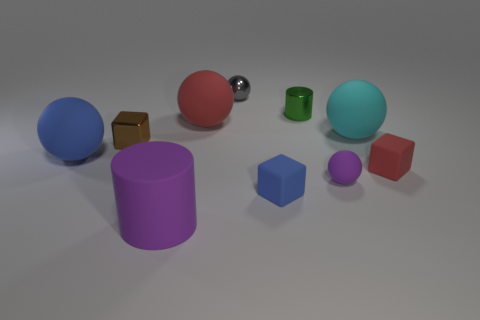Subtract all gray spheres. How many spheres are left? 4 Subtract 2 balls. How many balls are left? 3 Subtract all gray spheres. How many spheres are left? 4 Subtract all green balls. Subtract all gray cubes. How many balls are left? 5 Subtract all cubes. How many objects are left? 7 Add 5 small green metal objects. How many small green metal objects are left? 6 Add 4 cylinders. How many cylinders exist? 6 Subtract 0 green balls. How many objects are left? 10 Subtract all red spheres. Subtract all tiny blue objects. How many objects are left? 8 